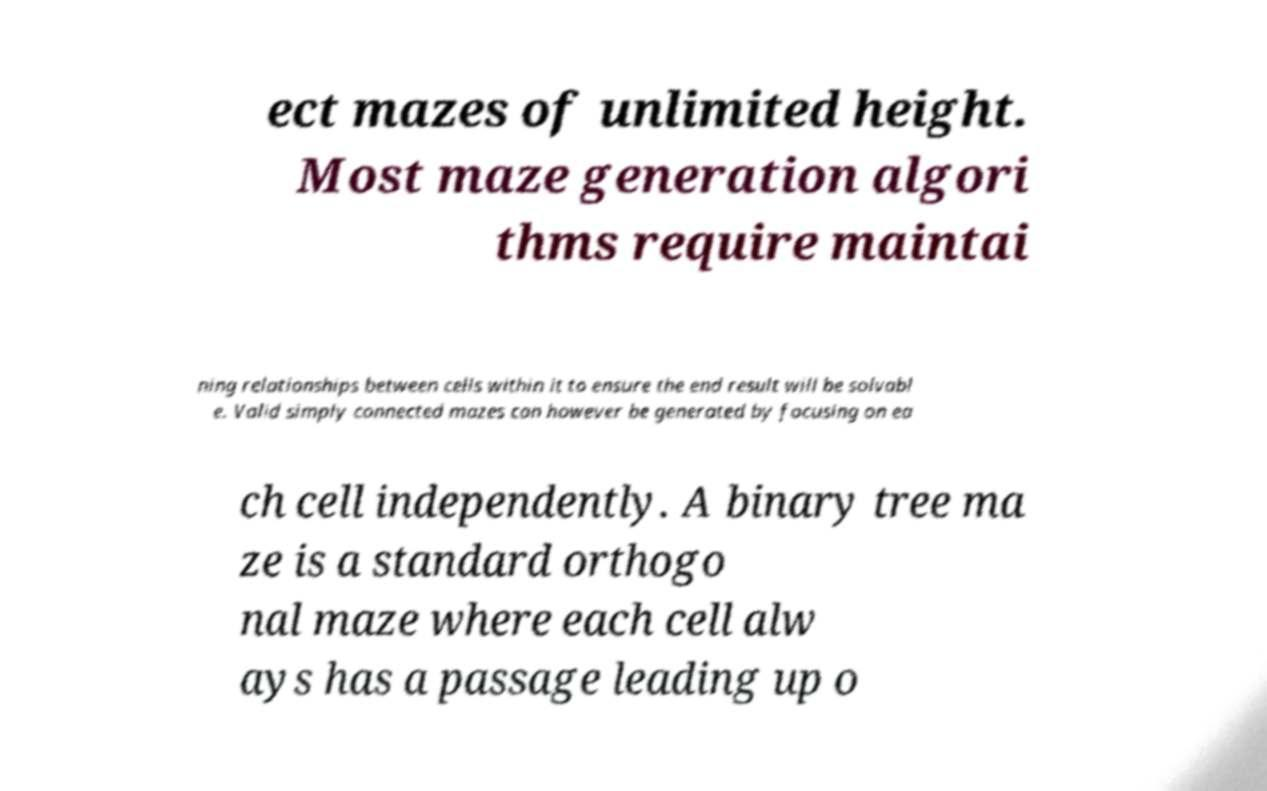There's text embedded in this image that I need extracted. Can you transcribe it verbatim? ect mazes of unlimited height. Most maze generation algori thms require maintai ning relationships between cells within it to ensure the end result will be solvabl e. Valid simply connected mazes can however be generated by focusing on ea ch cell independently. A binary tree ma ze is a standard orthogo nal maze where each cell alw ays has a passage leading up o 